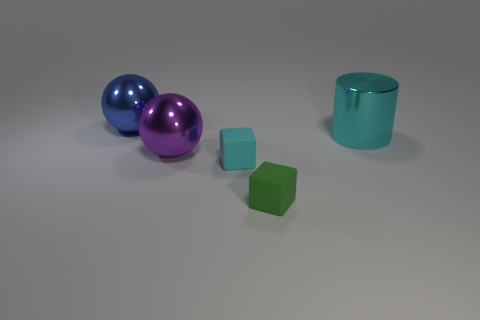Add 2 small green matte objects. How many objects exist? 7 Subtract all blocks. How many objects are left? 3 Add 2 blocks. How many blocks exist? 4 Subtract 1 cyan cylinders. How many objects are left? 4 Subtract all red matte cylinders. Subtract all rubber things. How many objects are left? 3 Add 4 big purple balls. How many big purple balls are left? 5 